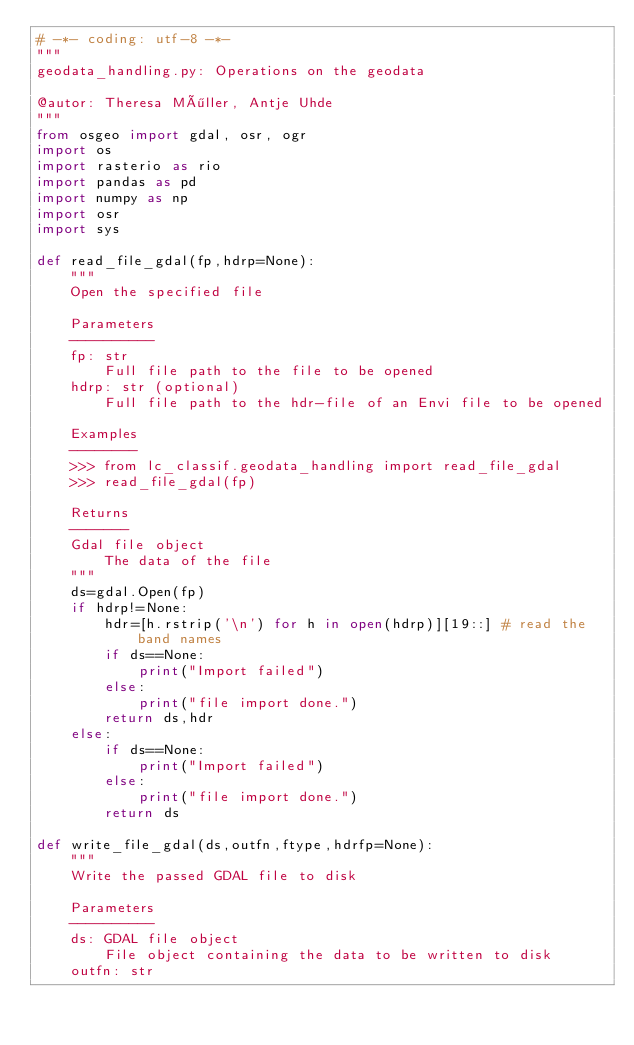Convert code to text. <code><loc_0><loc_0><loc_500><loc_500><_Python_># -*- coding: utf-8 -*-
"""
geodata_handling.py: Operations on the geodata

@autor: Theresa Möller, Antje Uhde
"""
from osgeo import gdal, osr, ogr
import os
import rasterio as rio
import pandas as pd
import numpy as np
import osr
import sys

def read_file_gdal(fp,hdrp=None):
    """
    Open the specified file

    Parameters
    ----------
    fp: str
        Full file path to the file to be opened
    hdrp: str (optional) 
        Full file path to the hdr-file of an Envi file to be opened

    Examples
    --------
    >>> from lc_classif.geodata_handling import read_file_gdal
    >>> read_file_gdal(fp)

    Returns
    -------
    Gdal file object
        The data of the file
    """
    ds=gdal.Open(fp)
    if hdrp!=None:
        hdr=[h.rstrip('\n') for h in open(hdrp)][19::] # read the band names
        if ds==None:
            print("Import failed")
        else:
            print("file import done.")
        return ds,hdr
    else:
        if ds==None:
            print("Import failed")
        else:
            print("file import done.")
        return ds

def write_file_gdal(ds,outfn,ftype,hdrfp=None):
    """
    Write the passed GDAL file to disk

    Parameters
    ----------
    ds: GDAL file object
        File object containing the data to be written to disk
    outfn: str</code> 